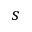Convert formula to latex. <formula><loc_0><loc_0><loc_500><loc_500>s</formula> 